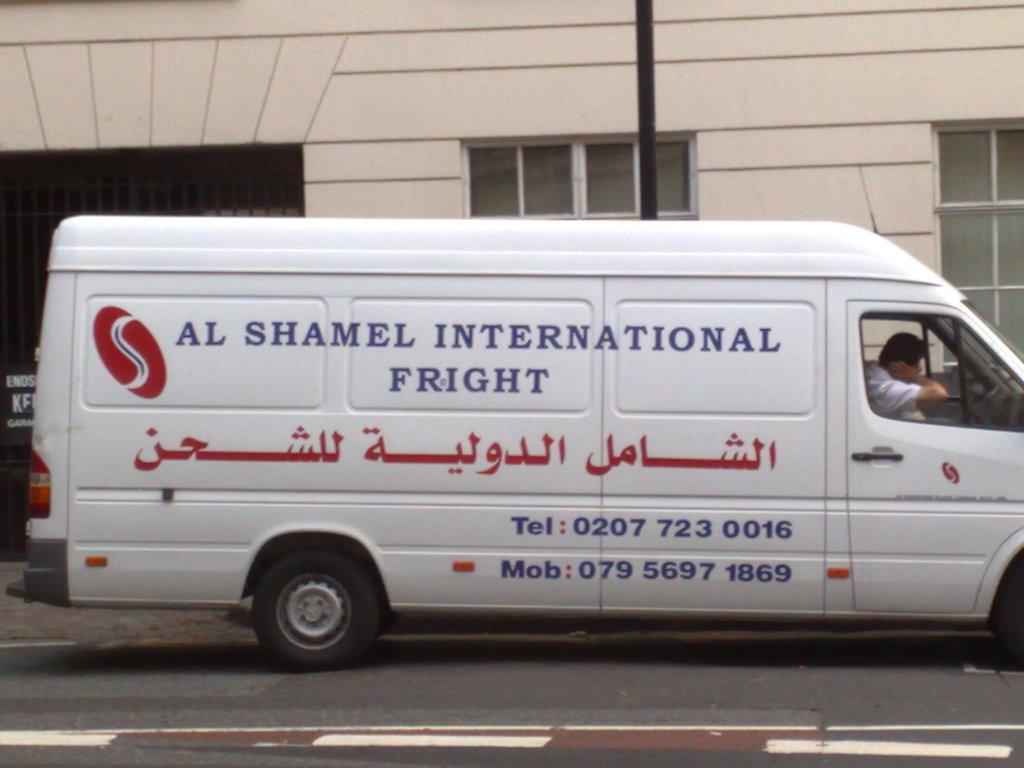What's the telephone number?
Give a very brief answer. 0207 723 0016. Is this a taxi?
Make the answer very short. No. 